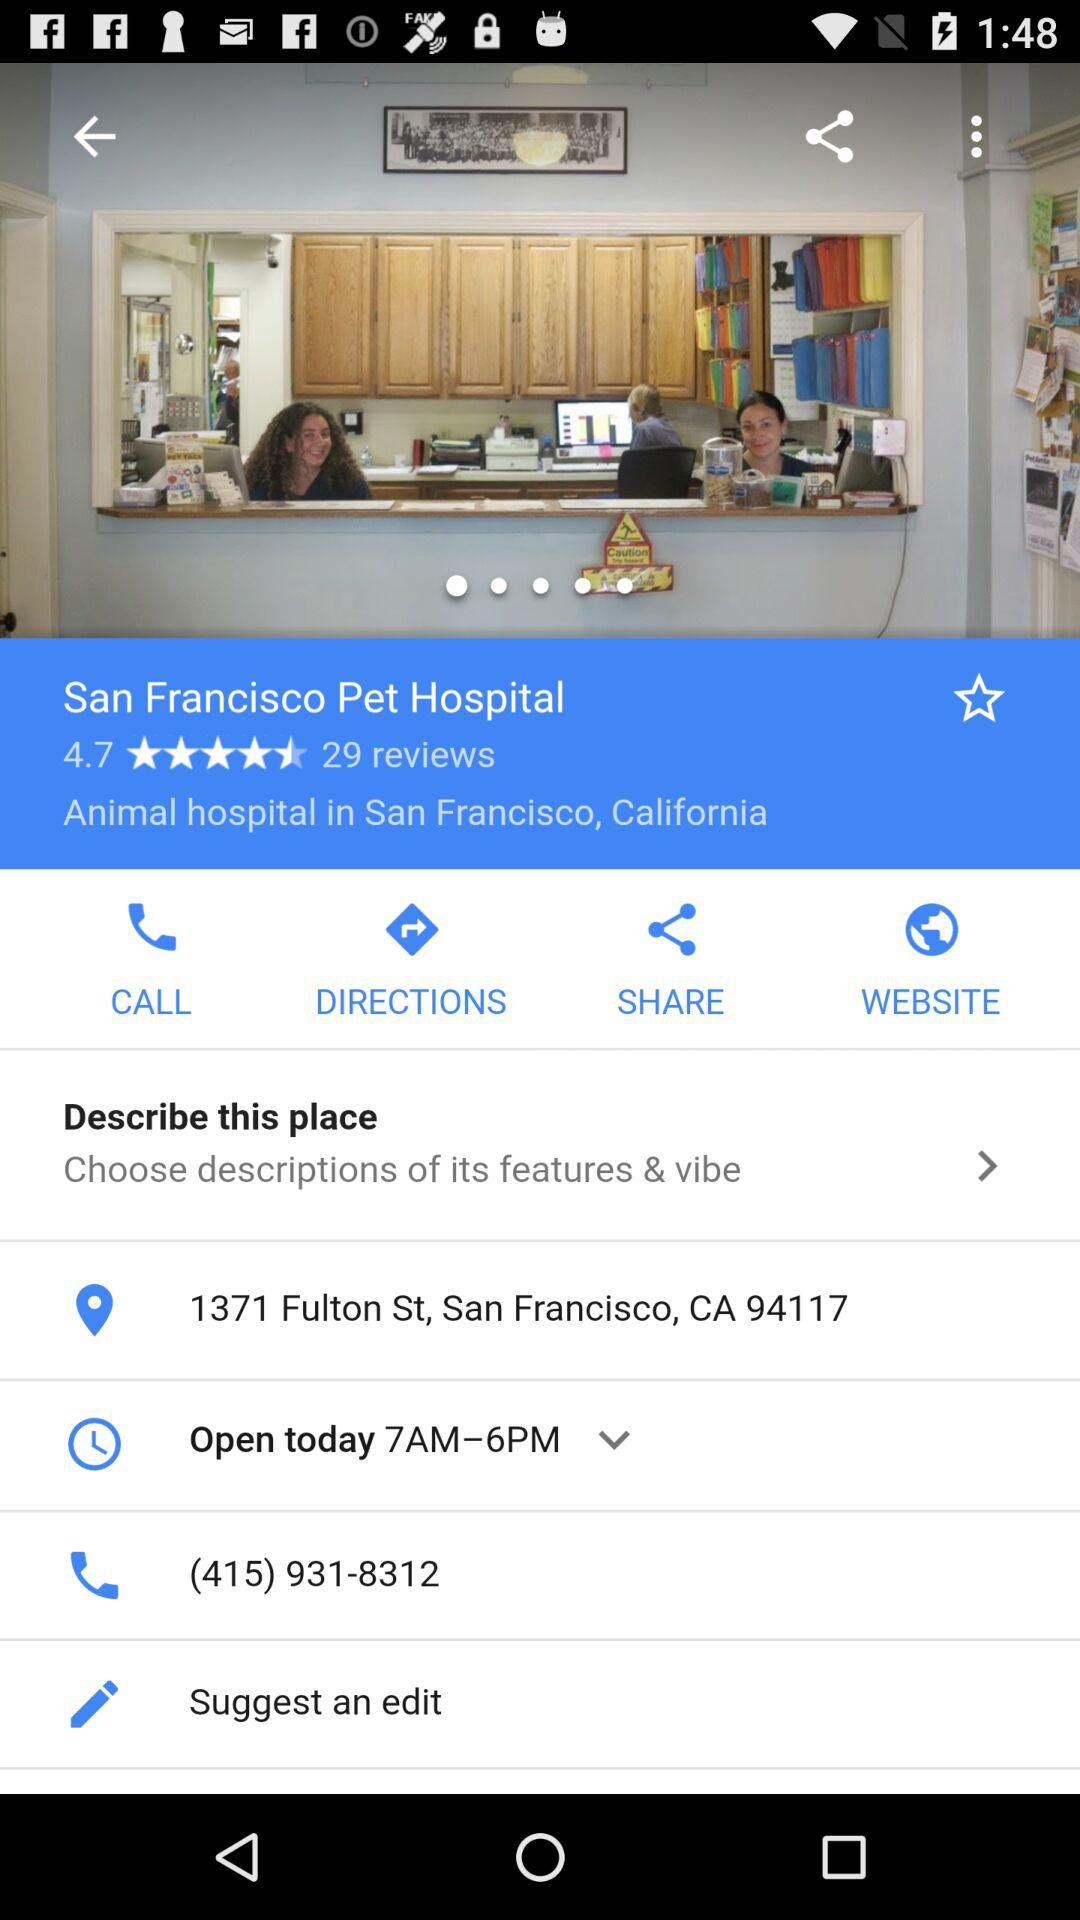How many reviews are there for the San Francisco pet hospital? There are 29 reviews for the San Francisco pet hospital. 